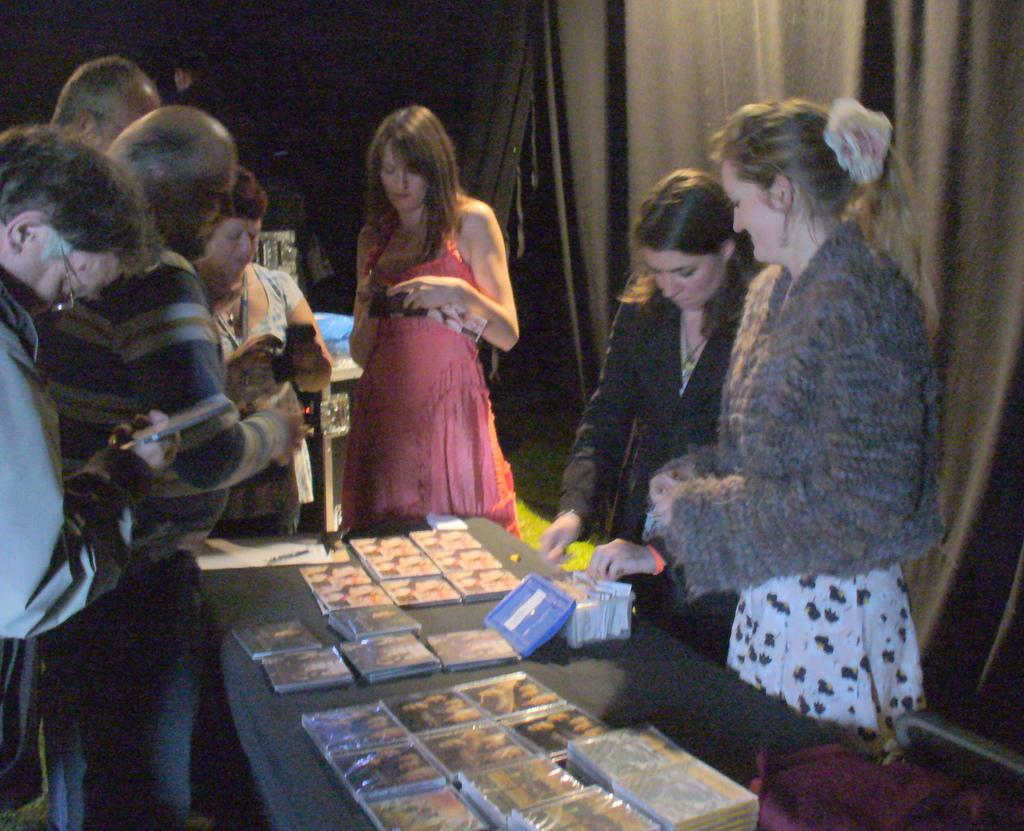How many people are in the image? There is a group of people in the image, but the exact number is not specified. What are the people in the image doing? The people are standing in the image. What is located in front of the group of people? There is a table in front of the group of people. What is on the table? There is a box, a writing pad, and other objects on the table. What can be seen in the background of the image? There are curtains visible in the background of the image. What color is the eye of the person in the image? There is no mention of an eye or a person's eye color in the image. 